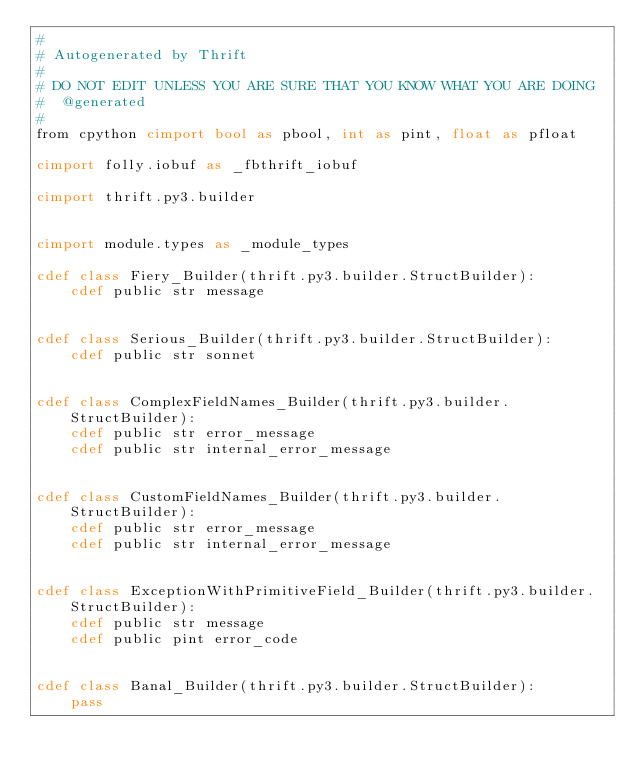Convert code to text. <code><loc_0><loc_0><loc_500><loc_500><_Cython_>#
# Autogenerated by Thrift
#
# DO NOT EDIT UNLESS YOU ARE SURE THAT YOU KNOW WHAT YOU ARE DOING
#  @generated
#
from cpython cimport bool as pbool, int as pint, float as pfloat

cimport folly.iobuf as _fbthrift_iobuf

cimport thrift.py3.builder


cimport module.types as _module_types

cdef class Fiery_Builder(thrift.py3.builder.StructBuilder):
    cdef public str message


cdef class Serious_Builder(thrift.py3.builder.StructBuilder):
    cdef public str sonnet


cdef class ComplexFieldNames_Builder(thrift.py3.builder.StructBuilder):
    cdef public str error_message
    cdef public str internal_error_message


cdef class CustomFieldNames_Builder(thrift.py3.builder.StructBuilder):
    cdef public str error_message
    cdef public str internal_error_message


cdef class ExceptionWithPrimitiveField_Builder(thrift.py3.builder.StructBuilder):
    cdef public str message
    cdef public pint error_code


cdef class Banal_Builder(thrift.py3.builder.StructBuilder):
    pass


</code> 